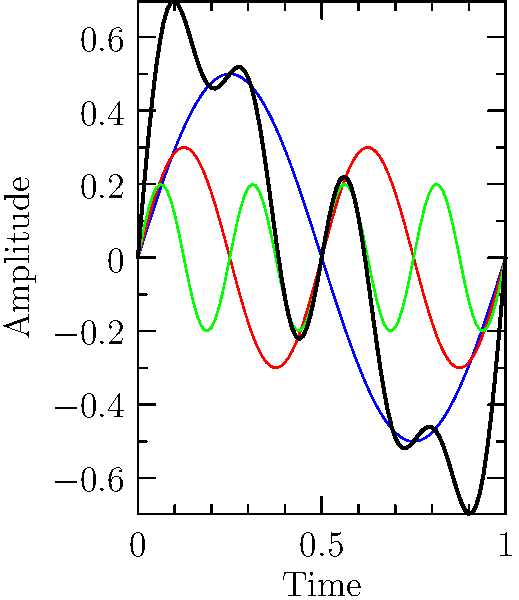Analyze the frequency spectrum represented in the waveform diagram. Which instrument is most likely being depicted, and how does this relate to the timbre characteristics observed in jazz performances? To answer this question, let's analyze the waveform step-by-step:

1. The diagram shows four waveforms: a fundamental frequency (blue), a 2nd harmonic (red), a 4th harmonic (green), and a combined waveform (black).

2. The presence of harmonics indicates a complex tone, which is characteristic of most musical instruments.

3. The relative strengths of the harmonics provide clues about the instrument:
   - The fundamental is strongest (amplitude 0.5)
   - The 2nd harmonic is moderately strong (amplitude 0.3)
   - The 4th harmonic is present but weaker (amplitude 0.2)

4. This harmonic structure, with strong lower harmonics and progressively weaker higher harmonics, is typical of brass instruments.

5. In the context of jazz, the trumpet is a prominent brass instrument known for its bright, penetrating tone.

6. The trumpet's timbre is characterized by:
   - A strong fundamental frequency
   - Significant presence of lower harmonics (especially 2nd and 3rd)
   - Gradually decreasing strength of higher harmonics

7. This harmonic structure contributes to the trumpet's ability to cut through the mix in jazz ensembles, making it ideal for lead parts and solos.

8. In jazz performances, trumpeters often manipulate their instrument's timbre through techniques like growling, half-valving, or using mutes, which would alter the harmonic content in ways that could be analyzed using similar waveform diagrams.

Given these observations, the waveform most likely represents a trumpet, a key instrument in many jazz performances.
Answer: Trumpet 